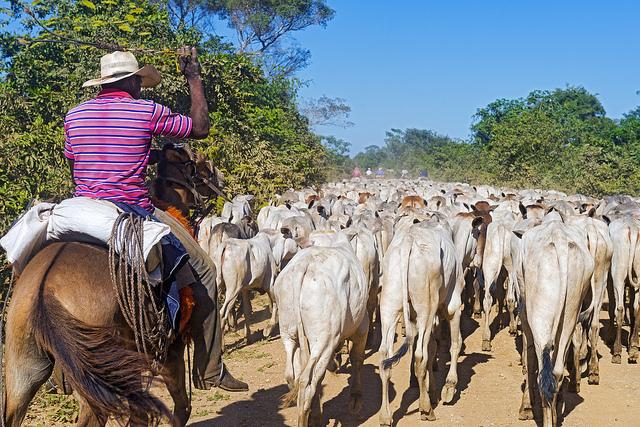What color is the horse?
Write a very short answer. Brown. Which hand is raised in the air?
Short answer required. Right. What is the man's job?
Write a very short answer. Herding cattle. 